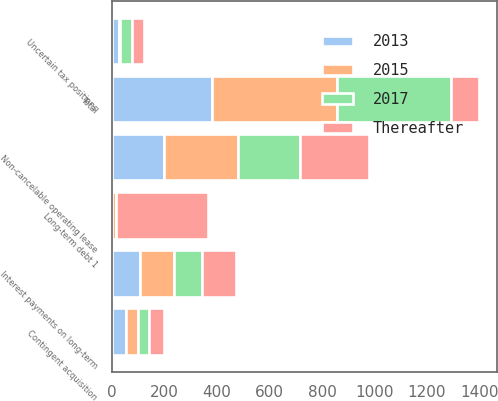Convert chart to OTSL. <chart><loc_0><loc_0><loc_500><loc_500><stacked_bar_chart><ecel><fcel>Long-term debt 1<fcel>Interest payments on long-term<fcel>Non-cancelable operating lease<fcel>Contingent acquisition<fcel>Uncertain tax positions<fcel>Total<nl><fcel>2015<fcel>16.1<fcel>127.3<fcel>282.2<fcel>46.5<fcel>4.5<fcel>476.6<nl><fcel>Thereafter<fcel>350<fcel>130.4<fcel>261.1<fcel>56.2<fcel>46.4<fcel>106.5<nl><fcel>2017<fcel>0.1<fcel>108.5<fcel>236.1<fcel>42.6<fcel>45.8<fcel>433.1<nl><fcel>2013<fcel>0.1<fcel>106.5<fcel>198.2<fcel>52.1<fcel>25.4<fcel>382.3<nl></chart> 